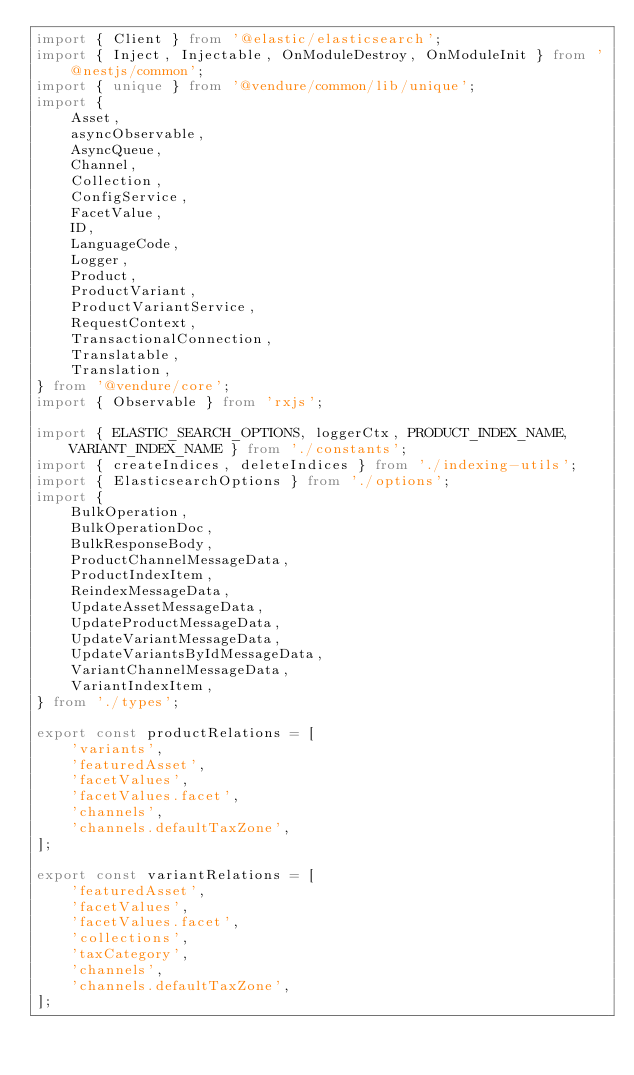Convert code to text. <code><loc_0><loc_0><loc_500><loc_500><_TypeScript_>import { Client } from '@elastic/elasticsearch';
import { Inject, Injectable, OnModuleDestroy, OnModuleInit } from '@nestjs/common';
import { unique } from '@vendure/common/lib/unique';
import {
    Asset,
    asyncObservable,
    AsyncQueue,
    Channel,
    Collection,
    ConfigService,
    FacetValue,
    ID,
    LanguageCode,
    Logger,
    Product,
    ProductVariant,
    ProductVariantService,
    RequestContext,
    TransactionalConnection,
    Translatable,
    Translation,
} from '@vendure/core';
import { Observable } from 'rxjs';

import { ELASTIC_SEARCH_OPTIONS, loggerCtx, PRODUCT_INDEX_NAME, VARIANT_INDEX_NAME } from './constants';
import { createIndices, deleteIndices } from './indexing-utils';
import { ElasticsearchOptions } from './options';
import {
    BulkOperation,
    BulkOperationDoc,
    BulkResponseBody,
    ProductChannelMessageData,
    ProductIndexItem,
    ReindexMessageData,
    UpdateAssetMessageData,
    UpdateProductMessageData,
    UpdateVariantMessageData,
    UpdateVariantsByIdMessageData,
    VariantChannelMessageData,
    VariantIndexItem,
} from './types';

export const productRelations = [
    'variants',
    'featuredAsset',
    'facetValues',
    'facetValues.facet',
    'channels',
    'channels.defaultTaxZone',
];

export const variantRelations = [
    'featuredAsset',
    'facetValues',
    'facetValues.facet',
    'collections',
    'taxCategory',
    'channels',
    'channels.defaultTaxZone',
];
</code> 